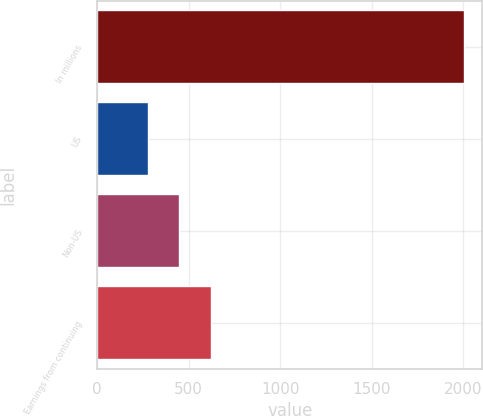Convert chart to OTSL. <chart><loc_0><loc_0><loc_500><loc_500><bar_chart><fcel>In millions<fcel>US<fcel>Non-US<fcel>Earnings from continuing<nl><fcel>2005<fcel>276<fcel>448.9<fcel>621.8<nl></chart> 